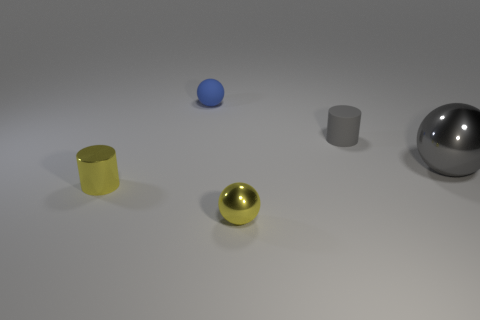Add 5 large shiny objects. How many objects exist? 10 Subtract all balls. How many objects are left? 2 Add 1 yellow shiny spheres. How many yellow shiny spheres are left? 2 Add 5 big blocks. How many big blocks exist? 5 Subtract 0 purple cubes. How many objects are left? 5 Subtract all small blue spheres. Subtract all small gray cylinders. How many objects are left? 3 